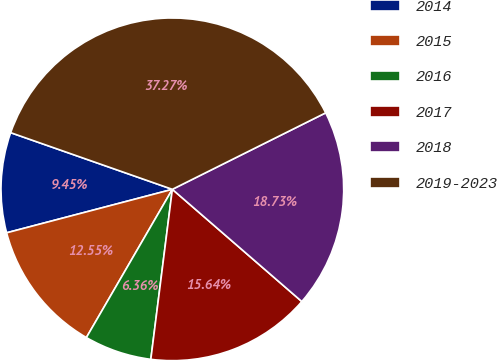<chart> <loc_0><loc_0><loc_500><loc_500><pie_chart><fcel>2014<fcel>2015<fcel>2016<fcel>2017<fcel>2018<fcel>2019-2023<nl><fcel>9.45%<fcel>12.55%<fcel>6.36%<fcel>15.64%<fcel>18.73%<fcel>37.27%<nl></chart> 